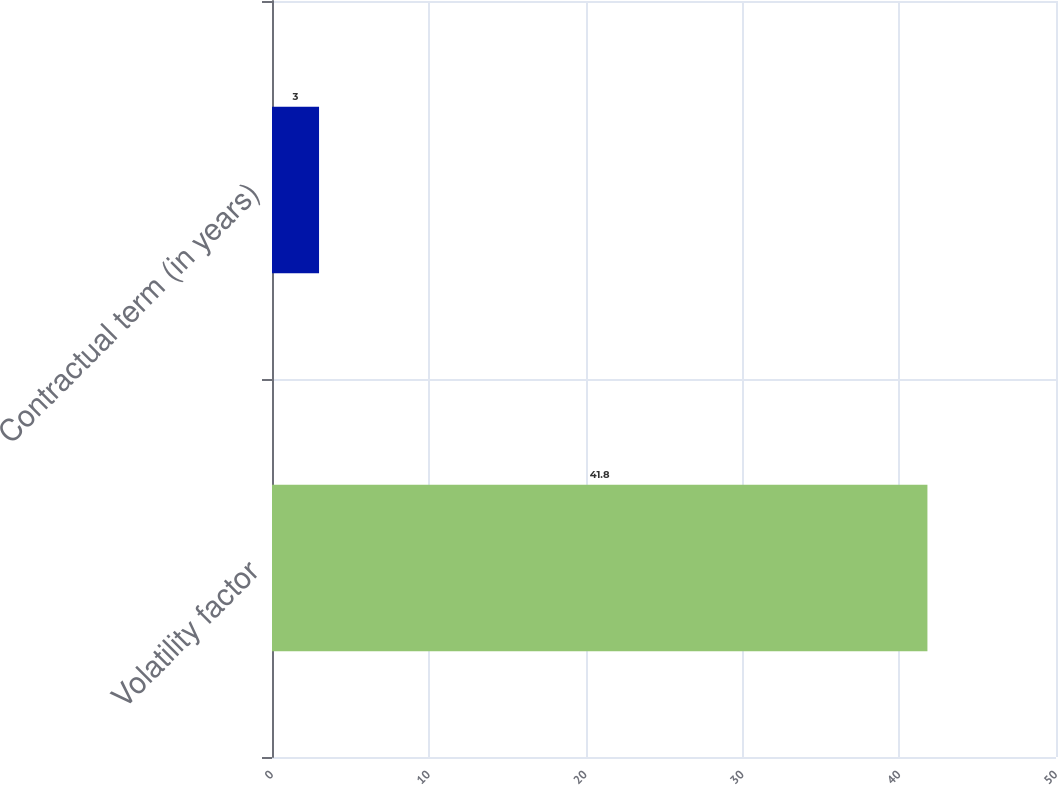Convert chart to OTSL. <chart><loc_0><loc_0><loc_500><loc_500><bar_chart><fcel>Volatility factor<fcel>Contractual term (in years)<nl><fcel>41.8<fcel>3<nl></chart> 